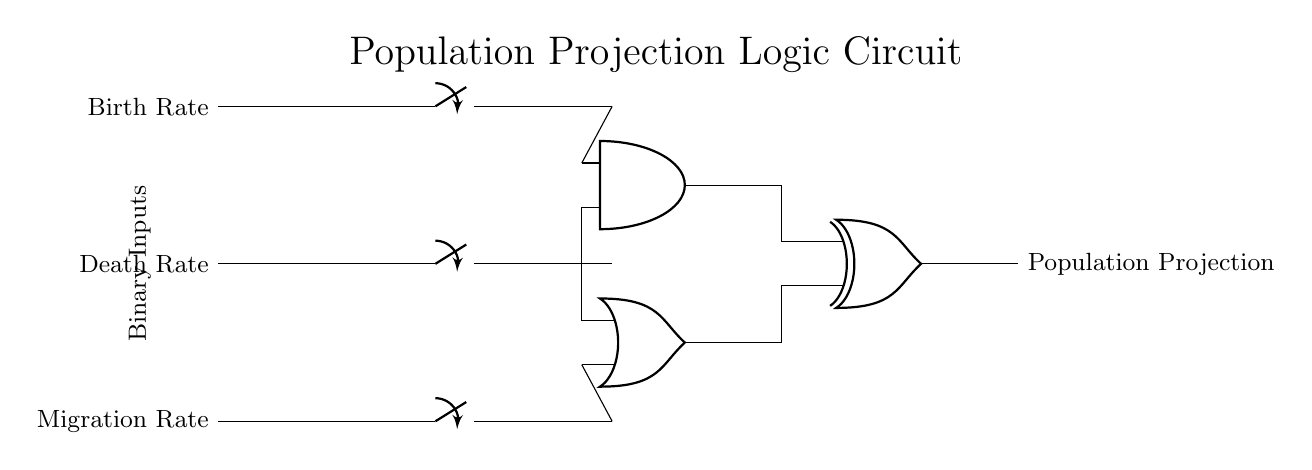What are the three binary inputs to the circuit? The circuit has three binary inputs: Birth Rate, Death Rate, and Migration Rate. These inputs are represented at the left side of the diagram.
Answer: Birth Rate, Death Rate, Migration Rate What type of logic gate combines the Birth Rate and Death Rate inputs? An AND gate is used, which requires that both the Birth Rate and Death Rate inputs be true (or 1) for its output to be true (1). This is indicated by the AND gate symbol in the circuit.
Answer: AND What is the role of the OR gate in this circuit? The OR gate combines the two inputs: Death Rate and Migration Rate. Its output will be true if at least one of these inputs is true, which suggests that either can contribute positively to the population projection.
Answer: To combine Death Rate and Migration Rate Which logic gate produces the final output of the circuit? The final output, labeled as Population Projection, is produced by the XOR gate. This gate will output true if there is an odd number of true inputs.
Answer: XOR gate How many outputs does the circuit have? The circuit has only one output, which is the Population Projection. This is shown at the rightmost part of the circuit diagram.
Answer: One output What happens when both the AND output and OR output are true? When both outputs are true, the XOR gate will output false. In XOR logic, true inputs lead to an even number of true outputs which resolves to false. Therefore, the population projection will indicate neutral.
Answer: Outputs false 